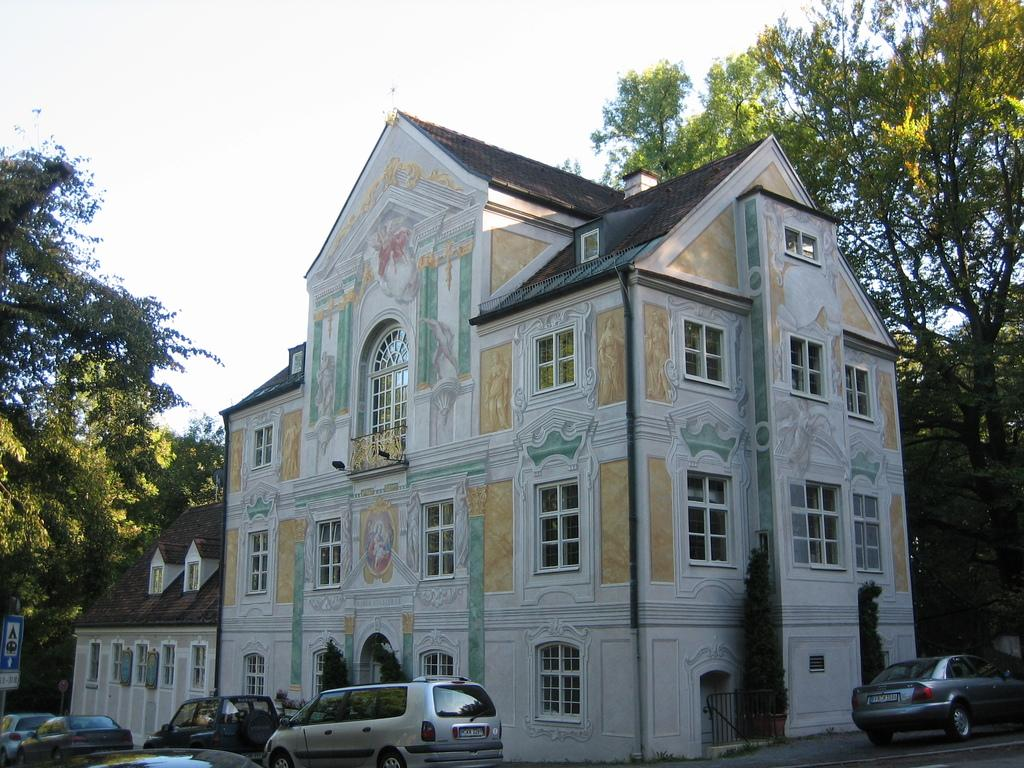What is the main structure in the picture? There is a building in the picture. What can be seen near the building? Cars are parked in front of and beside the building. What is visible in the background of the picture? There are trees in the backdrop of the picture. How is the sky depicted in the picture? The sky is clear in the picture. Can you hear the beast laughing in the picture? There is no beast or laughter present in the picture; it only features a building, parked cars, trees, and a clear sky. 